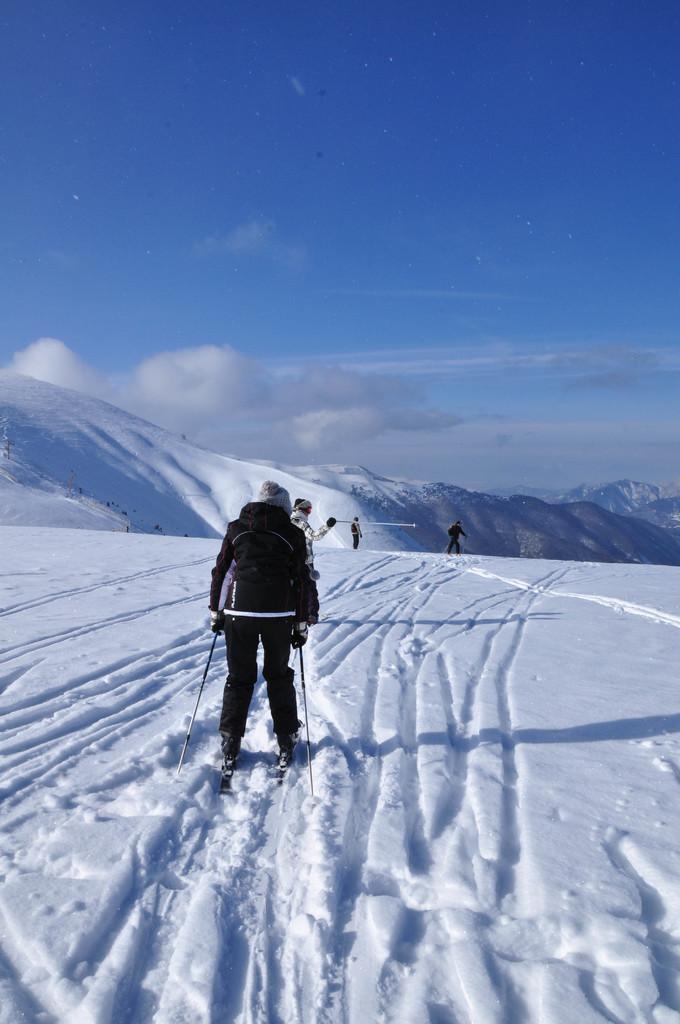Can you describe this image briefly? This picture is of outside. In the foreground there is a lot of snow and a person skiing and in the background we can see a sky, clouds and some Hills and there are same persons. 